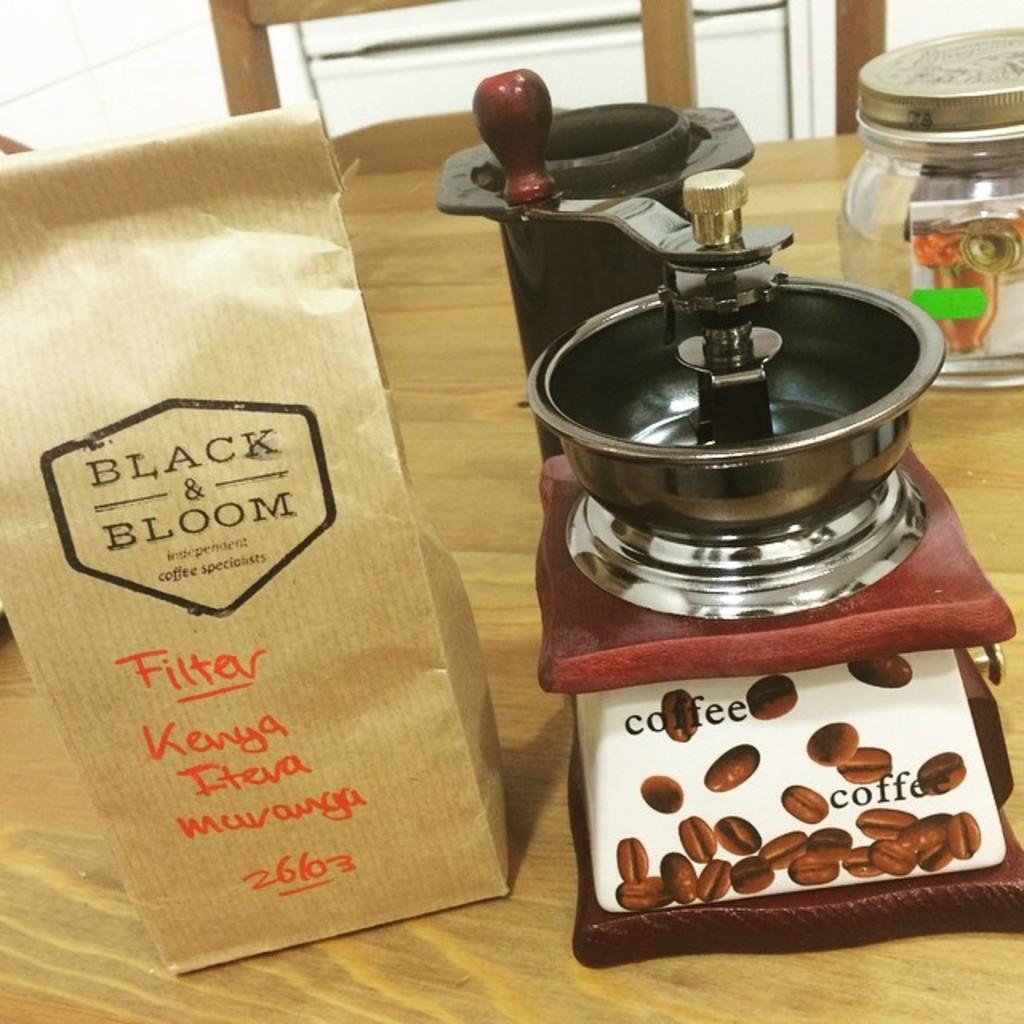What is the kind of coffee?
Offer a very short reply. Black & bloom. Are the beans from kenya?
Your answer should be very brief. Yes. 